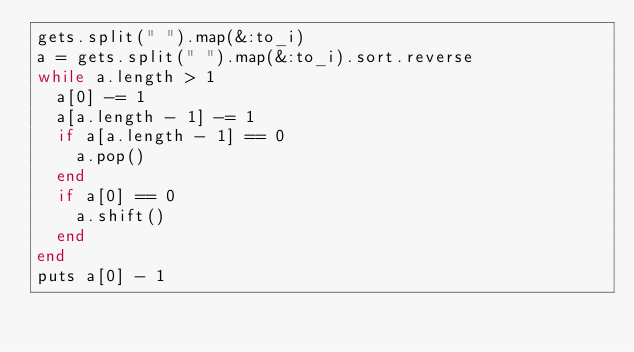Convert code to text. <code><loc_0><loc_0><loc_500><loc_500><_Ruby_>gets.split(" ").map(&:to_i)
a = gets.split(" ").map(&:to_i).sort.reverse
while a.length > 1
  a[0] -= 1
  a[a.length - 1] -= 1
  if a[a.length - 1] == 0
    a.pop()
  end
  if a[0] == 0
    a.shift()
  end
end
puts a[0] - 1
</code> 